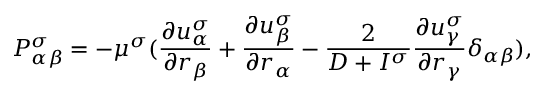<formula> <loc_0><loc_0><loc_500><loc_500>P _ { \alpha \beta } ^ { \sigma } = - \mu ^ { \sigma } ( \frac { \partial u _ { \alpha } ^ { \sigma } } { \partial r _ { \beta } } + \frac { \partial u _ { \beta } ^ { \sigma } } { \partial r _ { \alpha } } - \frac { 2 } { D + I ^ { \sigma } } \frac { \partial u _ { \gamma } ^ { \sigma } } { \partial r _ { \gamma } } \delta _ { \alpha \beta } ) ,</formula> 